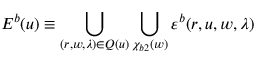Convert formula to latex. <formula><loc_0><loc_0><loc_500><loc_500>E ^ { b } ( u ) \equiv \bigcup _ { ( r , w , \lambda ) \in Q ( u ) } \bigcup _ { \chi _ { b 2 } ( w ) } \varepsilon ^ { b } ( r , u , w , \lambda )</formula> 